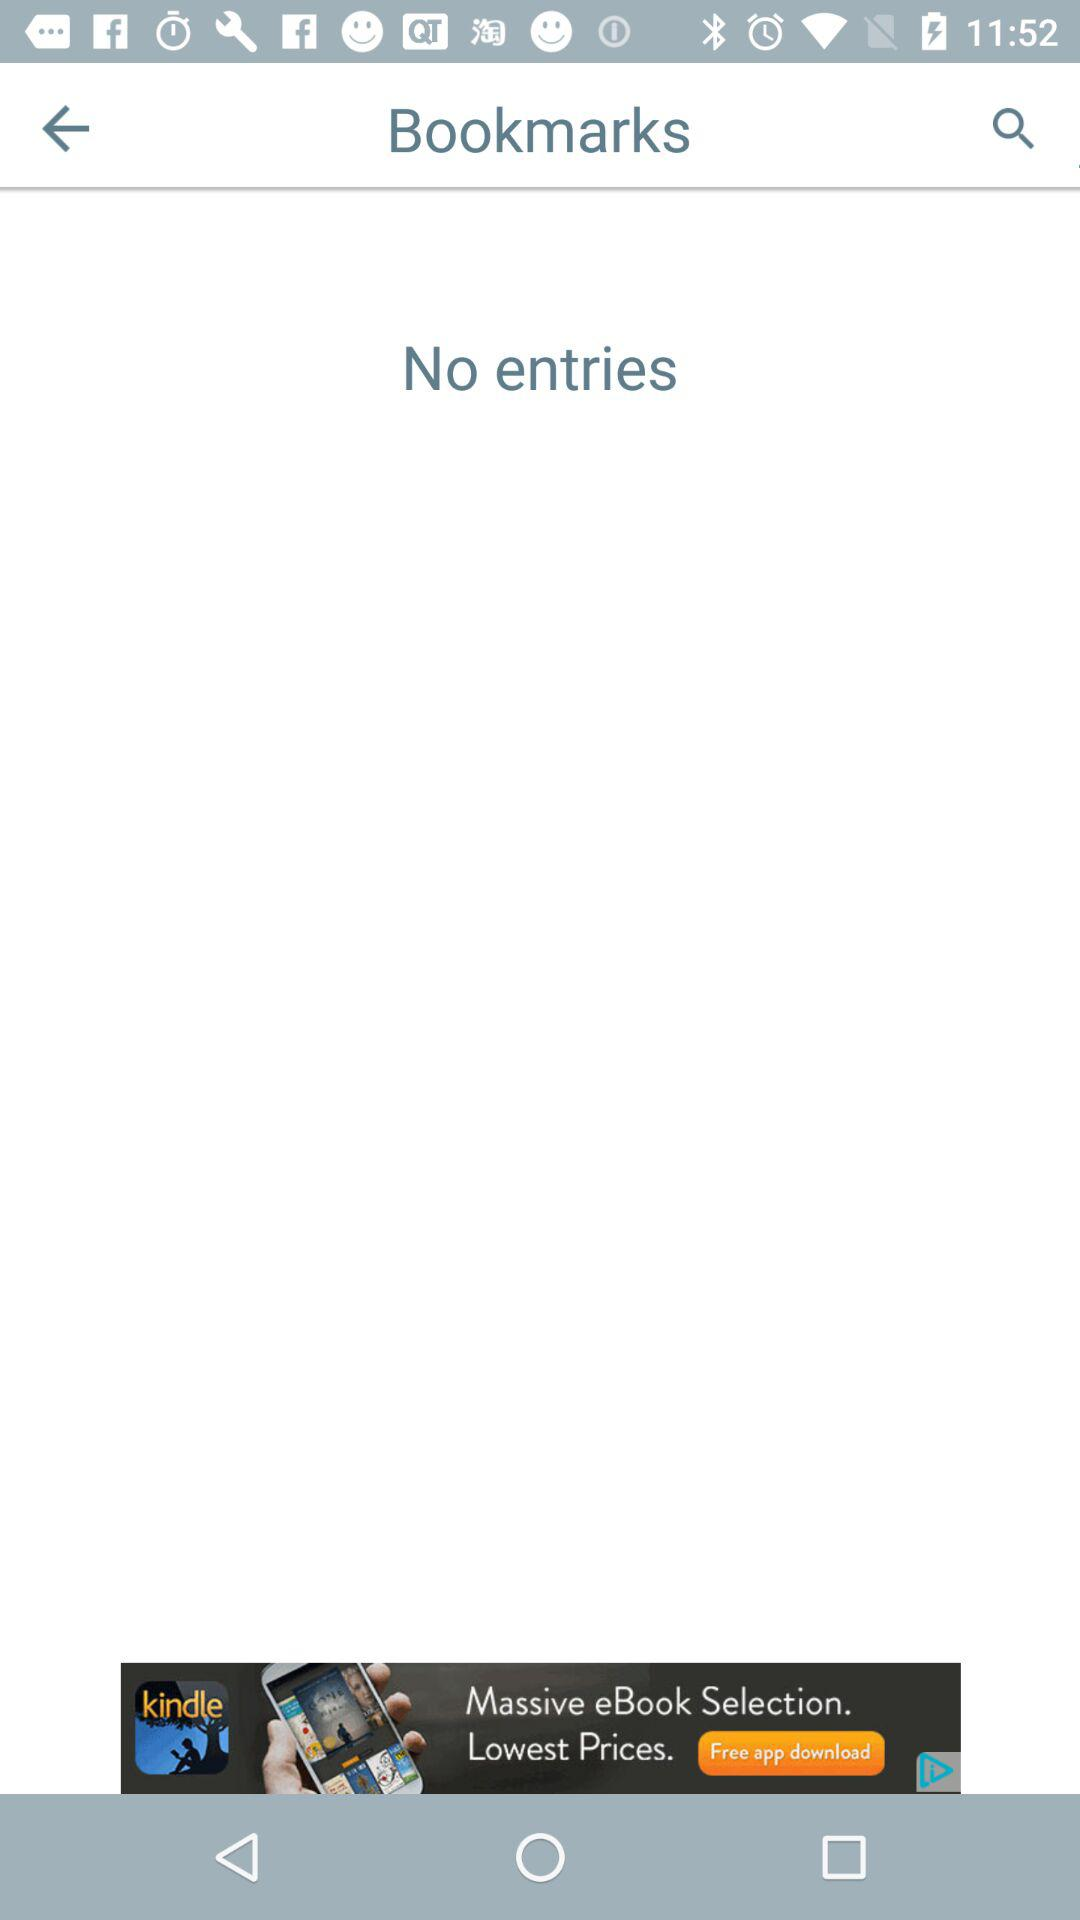Are there any entries? There are no entries. 